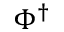<formula> <loc_0><loc_0><loc_500><loc_500>\Phi ^ { \dag }</formula> 